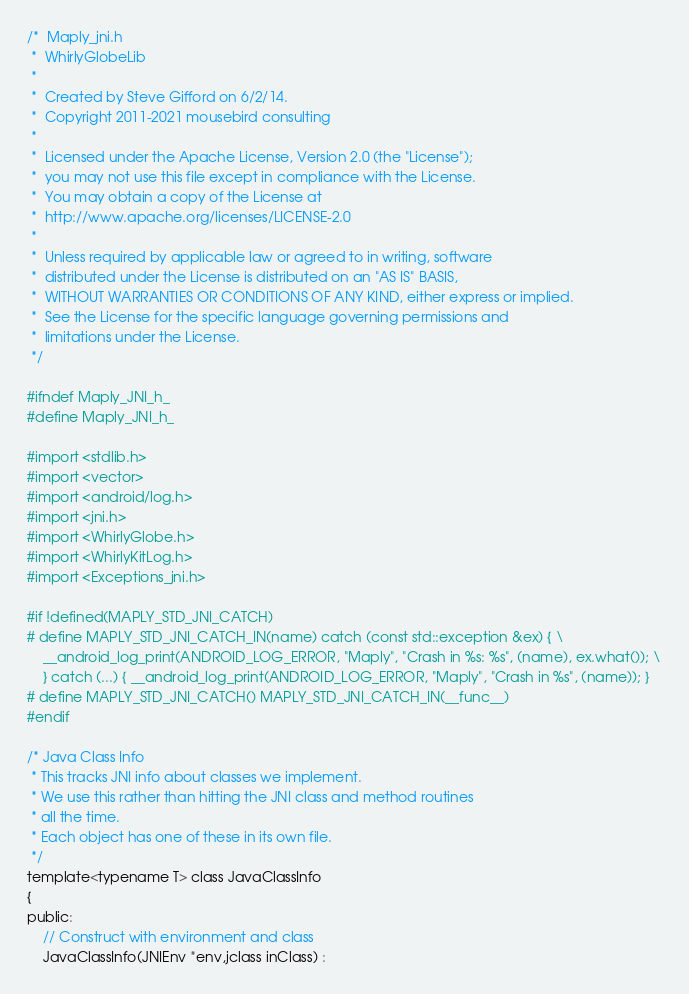Convert code to text. <code><loc_0><loc_0><loc_500><loc_500><_C_>/*  Maply_jni.h
 *  WhirlyGlobeLib
 *
 *  Created by Steve Gifford on 6/2/14.
 *  Copyright 2011-2021 mousebird consulting
 *
 *  Licensed under the Apache License, Version 2.0 (the "License");
 *  you may not use this file except in compliance with the License.
 *  You may obtain a copy of the License at
 *  http://www.apache.org/licenses/LICENSE-2.0
 *
 *  Unless required by applicable law or agreed to in writing, software
 *  distributed under the License is distributed on an "AS IS" BASIS,
 *  WITHOUT WARRANTIES OR CONDITIONS OF ANY KIND, either express or implied.
 *  See the License for the specific language governing permissions and
 *  limitations under the License.
 */

#ifndef Maply_JNI_h_
#define Maply_JNI_h_

#import <stdlib.h>
#import <vector>
#import <android/log.h>
#import <jni.h>
#import <WhirlyGlobe.h>
#import <WhirlyKitLog.h>
#import <Exceptions_jni.h>

#if !defined(MAPLY_STD_JNI_CATCH)
# define MAPLY_STD_JNI_CATCH_IN(name) catch (const std::exception &ex) { \
	__android_log_print(ANDROID_LOG_ERROR, "Maply", "Crash in %s: %s", (name), ex.what()); \
	} catch (...) { __android_log_print(ANDROID_LOG_ERROR, "Maply", "Crash in %s", (name)); }
# define MAPLY_STD_JNI_CATCH() MAPLY_STD_JNI_CATCH_IN(__func__)
#endif

/* Java Class Info
 * This tracks JNI info about classes we implement.
 * We use this rather than hitting the JNI class and method routines
 * all the time.
 * Each object has one of these in its own file.
 */
template<typename T> class JavaClassInfo
{
public:
	// Construct with environment and class
	JavaClassInfo(JNIEnv *env,jclass inClass) :</code> 